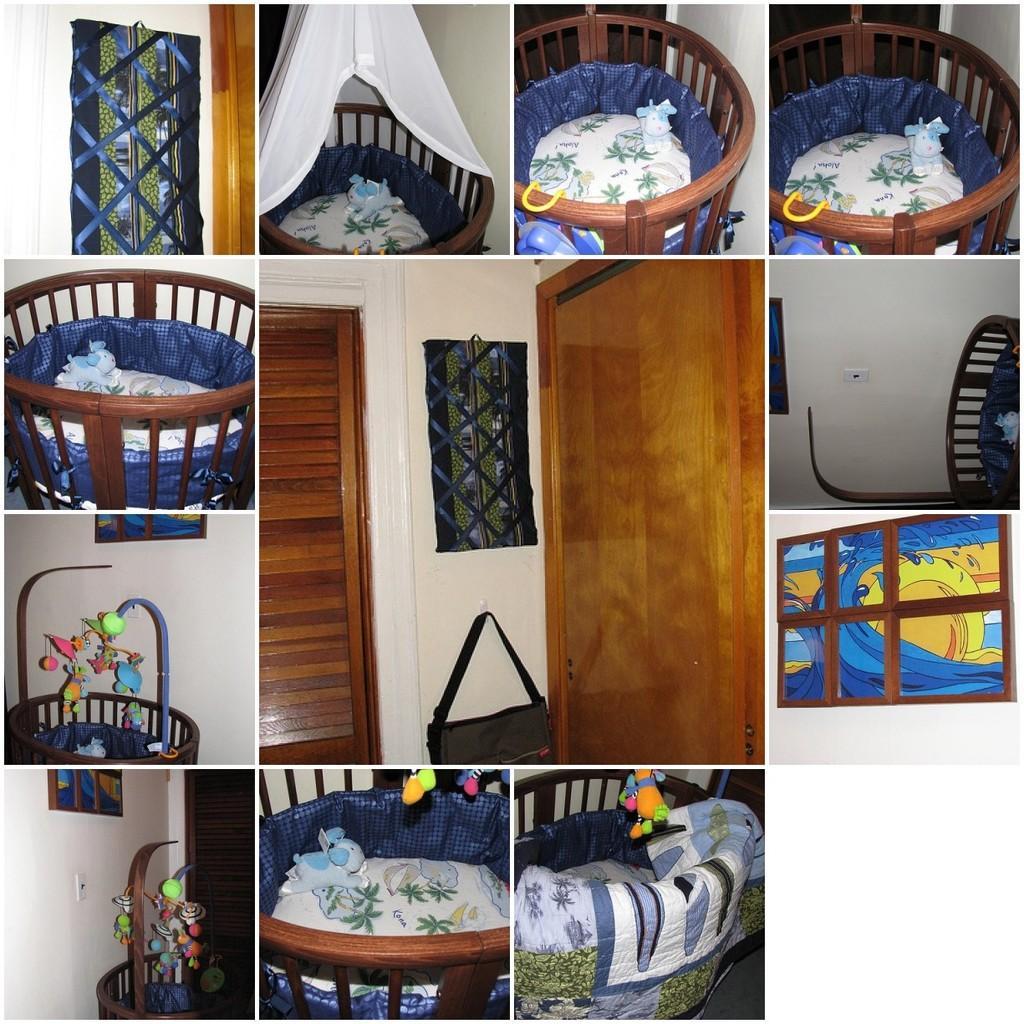Please provide a concise description of this image. In this image I see a collage of pics and in which few of them are showing the bed of a baby and I see the pic of a door over here and there is a bag on the wall. 